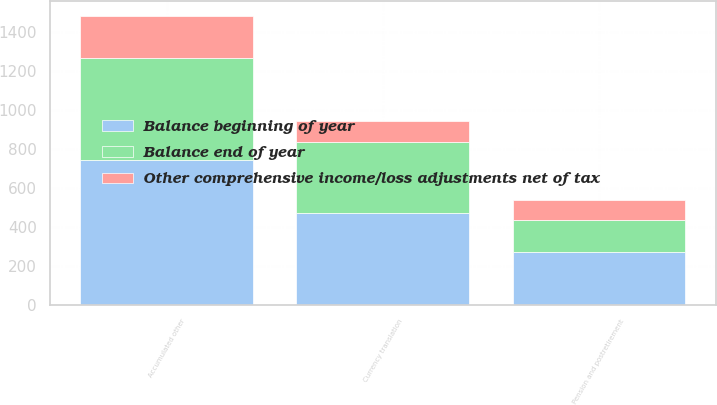Convert chart. <chart><loc_0><loc_0><loc_500><loc_500><stacked_bar_chart><ecel><fcel>Currency translation<fcel>Pension and postretirement<fcel>Accumulated other<nl><fcel>Balance end of year<fcel>364<fcel>168<fcel>524<nl><fcel>Other comprehensive income/loss adjustments net of tax<fcel>109<fcel>102<fcel>219<nl><fcel>Balance beginning of year<fcel>473<fcel>270<fcel>743<nl></chart> 